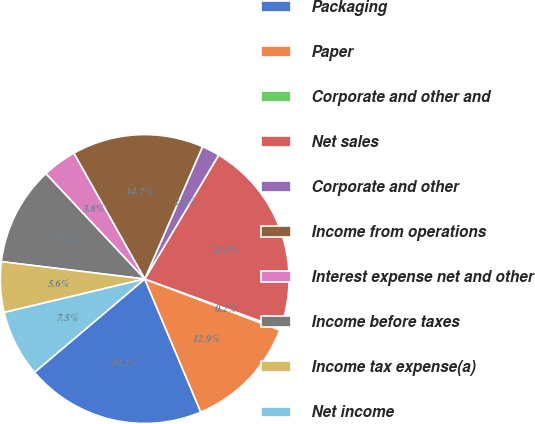Convert chart. <chart><loc_0><loc_0><loc_500><loc_500><pie_chart><fcel>Packaging<fcel>Paper<fcel>Corporate and other and<fcel>Net sales<fcel>Corporate and other<fcel>Income from operations<fcel>Interest expense net and other<fcel>Income before taxes<fcel>Income tax expense(a)<fcel>Net income<nl><fcel>20.17%<fcel>12.91%<fcel>0.19%<fcel>21.99%<fcel>2.01%<fcel>14.72%<fcel>3.83%<fcel>11.09%<fcel>5.64%<fcel>7.46%<nl></chart> 